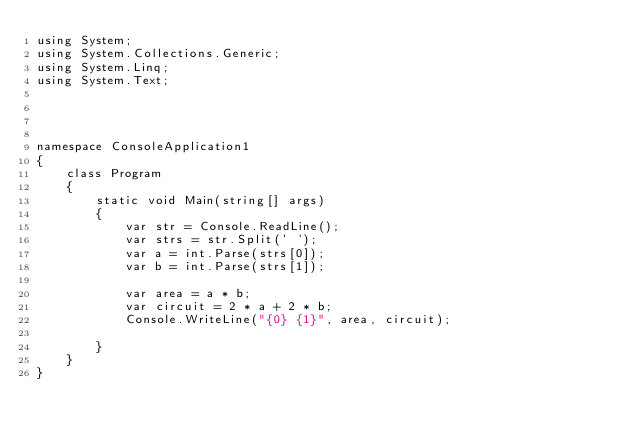<code> <loc_0><loc_0><loc_500><loc_500><_C#_>using System;
using System.Collections.Generic;
using System.Linq;
using System.Text;




namespace ConsoleApplication1
{
    class Program
    {
        static void Main(string[] args)
        {
            var str = Console.ReadLine();
            var strs = str.Split(' ');
            var a = int.Parse(strs[0]);
            var b = int.Parse(strs[1]);

            var area = a * b;
            var circuit = 2 * a + 2 * b;
            Console.WriteLine("{0} {1}", area, circuit);

        }  
    }
}</code> 